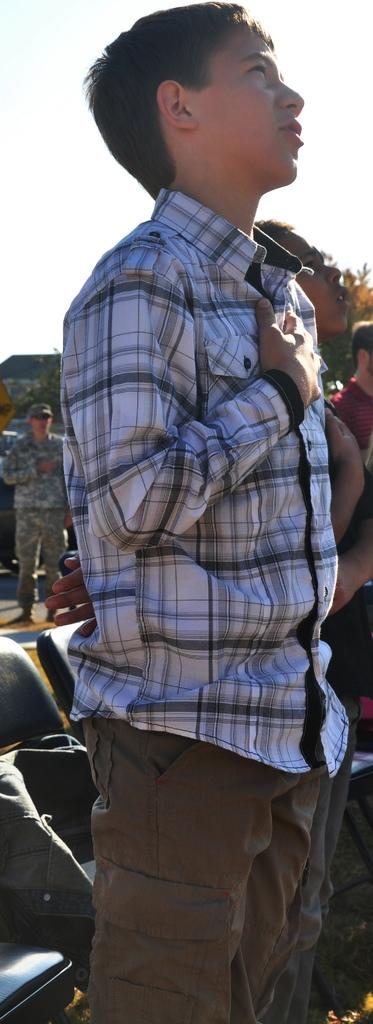What is happening in the image? There are people standing in the image. Where are the chairs located in the image? The chairs are on the left side of the image. What can be seen in the distance in the image? The sky is visible in the background of the image. What type of scientific experiment is being conducted in the image? There is no indication of a scientific experiment being conducted in the image. 